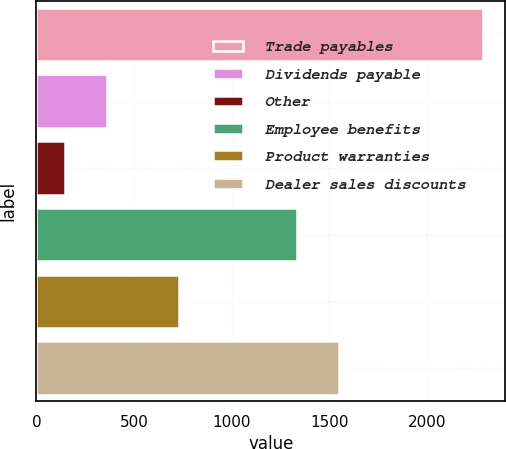Convert chart. <chart><loc_0><loc_0><loc_500><loc_500><bar_chart><fcel>Trade payables<fcel>Dividends payable<fcel>Other<fcel>Employee benefits<fcel>Product warranties<fcel>Dealer sales discounts<nl><fcel>2287<fcel>361<fcel>147<fcel>1337<fcel>733<fcel>1551<nl></chart> 